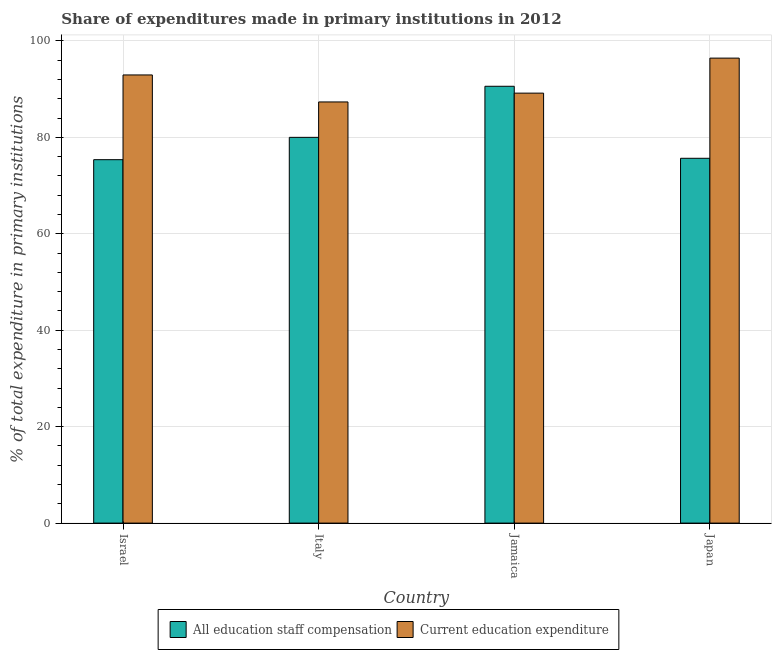How many different coloured bars are there?
Make the answer very short. 2. Are the number of bars per tick equal to the number of legend labels?
Your answer should be compact. Yes. Are the number of bars on each tick of the X-axis equal?
Provide a succinct answer. Yes. How many bars are there on the 3rd tick from the right?
Make the answer very short. 2. What is the label of the 3rd group of bars from the left?
Provide a short and direct response. Jamaica. What is the expenditure in education in Jamaica?
Provide a succinct answer. 89.18. Across all countries, what is the maximum expenditure in education?
Offer a terse response. 96.45. Across all countries, what is the minimum expenditure in staff compensation?
Provide a succinct answer. 75.38. In which country was the expenditure in staff compensation maximum?
Make the answer very short. Jamaica. What is the total expenditure in education in the graph?
Offer a very short reply. 365.95. What is the difference between the expenditure in education in Jamaica and that in Japan?
Keep it short and to the point. -7.26. What is the difference between the expenditure in staff compensation in Italy and the expenditure in education in Jamaica?
Make the answer very short. -9.17. What is the average expenditure in education per country?
Your answer should be very brief. 91.49. What is the difference between the expenditure in staff compensation and expenditure in education in Japan?
Keep it short and to the point. -20.78. What is the ratio of the expenditure in education in Israel to that in Italy?
Ensure brevity in your answer.  1.06. Is the expenditure in staff compensation in Israel less than that in Italy?
Provide a succinct answer. Yes. Is the difference between the expenditure in education in Italy and Japan greater than the difference between the expenditure in staff compensation in Italy and Japan?
Provide a short and direct response. No. What is the difference between the highest and the second highest expenditure in staff compensation?
Your response must be concise. 10.59. What is the difference between the highest and the lowest expenditure in education?
Your answer should be compact. 9.09. What does the 2nd bar from the left in Israel represents?
Provide a succinct answer. Current education expenditure. What does the 1st bar from the right in Jamaica represents?
Your answer should be very brief. Current education expenditure. How many bars are there?
Provide a short and direct response. 8. How many countries are there in the graph?
Provide a succinct answer. 4. What is the difference between two consecutive major ticks on the Y-axis?
Ensure brevity in your answer.  20. Does the graph contain grids?
Your answer should be very brief. Yes. Where does the legend appear in the graph?
Make the answer very short. Bottom center. What is the title of the graph?
Your response must be concise. Share of expenditures made in primary institutions in 2012. What is the label or title of the Y-axis?
Offer a very short reply. % of total expenditure in primary institutions. What is the % of total expenditure in primary institutions in All education staff compensation in Israel?
Offer a terse response. 75.38. What is the % of total expenditure in primary institutions of Current education expenditure in Israel?
Ensure brevity in your answer.  92.96. What is the % of total expenditure in primary institutions of All education staff compensation in Italy?
Provide a short and direct response. 80.01. What is the % of total expenditure in primary institutions in Current education expenditure in Italy?
Give a very brief answer. 87.36. What is the % of total expenditure in primary institutions in All education staff compensation in Jamaica?
Keep it short and to the point. 90.61. What is the % of total expenditure in primary institutions of Current education expenditure in Jamaica?
Offer a very short reply. 89.18. What is the % of total expenditure in primary institutions of All education staff compensation in Japan?
Your answer should be compact. 75.67. What is the % of total expenditure in primary institutions of Current education expenditure in Japan?
Make the answer very short. 96.45. Across all countries, what is the maximum % of total expenditure in primary institutions of All education staff compensation?
Your response must be concise. 90.61. Across all countries, what is the maximum % of total expenditure in primary institutions in Current education expenditure?
Make the answer very short. 96.45. Across all countries, what is the minimum % of total expenditure in primary institutions in All education staff compensation?
Your answer should be compact. 75.38. Across all countries, what is the minimum % of total expenditure in primary institutions of Current education expenditure?
Your response must be concise. 87.36. What is the total % of total expenditure in primary institutions in All education staff compensation in the graph?
Offer a terse response. 321.67. What is the total % of total expenditure in primary institutions in Current education expenditure in the graph?
Ensure brevity in your answer.  365.95. What is the difference between the % of total expenditure in primary institutions in All education staff compensation in Israel and that in Italy?
Keep it short and to the point. -4.63. What is the difference between the % of total expenditure in primary institutions of Current education expenditure in Israel and that in Italy?
Keep it short and to the point. 5.6. What is the difference between the % of total expenditure in primary institutions in All education staff compensation in Israel and that in Jamaica?
Make the answer very short. -15.23. What is the difference between the % of total expenditure in primary institutions of Current education expenditure in Israel and that in Jamaica?
Offer a very short reply. 3.78. What is the difference between the % of total expenditure in primary institutions in All education staff compensation in Israel and that in Japan?
Provide a short and direct response. -0.29. What is the difference between the % of total expenditure in primary institutions in Current education expenditure in Israel and that in Japan?
Provide a succinct answer. -3.49. What is the difference between the % of total expenditure in primary institutions in All education staff compensation in Italy and that in Jamaica?
Make the answer very short. -10.59. What is the difference between the % of total expenditure in primary institutions of Current education expenditure in Italy and that in Jamaica?
Your answer should be very brief. -1.83. What is the difference between the % of total expenditure in primary institutions in All education staff compensation in Italy and that in Japan?
Keep it short and to the point. 4.35. What is the difference between the % of total expenditure in primary institutions in Current education expenditure in Italy and that in Japan?
Give a very brief answer. -9.09. What is the difference between the % of total expenditure in primary institutions of All education staff compensation in Jamaica and that in Japan?
Give a very brief answer. 14.94. What is the difference between the % of total expenditure in primary institutions in Current education expenditure in Jamaica and that in Japan?
Your response must be concise. -7.26. What is the difference between the % of total expenditure in primary institutions of All education staff compensation in Israel and the % of total expenditure in primary institutions of Current education expenditure in Italy?
Give a very brief answer. -11.98. What is the difference between the % of total expenditure in primary institutions of All education staff compensation in Israel and the % of total expenditure in primary institutions of Current education expenditure in Jamaica?
Your answer should be compact. -13.8. What is the difference between the % of total expenditure in primary institutions in All education staff compensation in Israel and the % of total expenditure in primary institutions in Current education expenditure in Japan?
Keep it short and to the point. -21.07. What is the difference between the % of total expenditure in primary institutions of All education staff compensation in Italy and the % of total expenditure in primary institutions of Current education expenditure in Jamaica?
Keep it short and to the point. -9.17. What is the difference between the % of total expenditure in primary institutions of All education staff compensation in Italy and the % of total expenditure in primary institutions of Current education expenditure in Japan?
Give a very brief answer. -16.43. What is the difference between the % of total expenditure in primary institutions of All education staff compensation in Jamaica and the % of total expenditure in primary institutions of Current education expenditure in Japan?
Your answer should be very brief. -5.84. What is the average % of total expenditure in primary institutions in All education staff compensation per country?
Offer a terse response. 80.42. What is the average % of total expenditure in primary institutions of Current education expenditure per country?
Ensure brevity in your answer.  91.49. What is the difference between the % of total expenditure in primary institutions of All education staff compensation and % of total expenditure in primary institutions of Current education expenditure in Israel?
Make the answer very short. -17.58. What is the difference between the % of total expenditure in primary institutions of All education staff compensation and % of total expenditure in primary institutions of Current education expenditure in Italy?
Your answer should be compact. -7.34. What is the difference between the % of total expenditure in primary institutions in All education staff compensation and % of total expenditure in primary institutions in Current education expenditure in Jamaica?
Your answer should be compact. 1.42. What is the difference between the % of total expenditure in primary institutions of All education staff compensation and % of total expenditure in primary institutions of Current education expenditure in Japan?
Offer a terse response. -20.78. What is the ratio of the % of total expenditure in primary institutions in All education staff compensation in Israel to that in Italy?
Ensure brevity in your answer.  0.94. What is the ratio of the % of total expenditure in primary institutions in Current education expenditure in Israel to that in Italy?
Offer a terse response. 1.06. What is the ratio of the % of total expenditure in primary institutions in All education staff compensation in Israel to that in Jamaica?
Provide a short and direct response. 0.83. What is the ratio of the % of total expenditure in primary institutions in Current education expenditure in Israel to that in Jamaica?
Offer a very short reply. 1.04. What is the ratio of the % of total expenditure in primary institutions in Current education expenditure in Israel to that in Japan?
Provide a succinct answer. 0.96. What is the ratio of the % of total expenditure in primary institutions in All education staff compensation in Italy to that in Jamaica?
Your answer should be compact. 0.88. What is the ratio of the % of total expenditure in primary institutions in Current education expenditure in Italy to that in Jamaica?
Keep it short and to the point. 0.98. What is the ratio of the % of total expenditure in primary institutions in All education staff compensation in Italy to that in Japan?
Your answer should be very brief. 1.06. What is the ratio of the % of total expenditure in primary institutions in Current education expenditure in Italy to that in Japan?
Your answer should be very brief. 0.91. What is the ratio of the % of total expenditure in primary institutions of All education staff compensation in Jamaica to that in Japan?
Make the answer very short. 1.2. What is the ratio of the % of total expenditure in primary institutions in Current education expenditure in Jamaica to that in Japan?
Offer a very short reply. 0.92. What is the difference between the highest and the second highest % of total expenditure in primary institutions of All education staff compensation?
Make the answer very short. 10.59. What is the difference between the highest and the second highest % of total expenditure in primary institutions of Current education expenditure?
Keep it short and to the point. 3.49. What is the difference between the highest and the lowest % of total expenditure in primary institutions in All education staff compensation?
Give a very brief answer. 15.23. What is the difference between the highest and the lowest % of total expenditure in primary institutions in Current education expenditure?
Offer a very short reply. 9.09. 